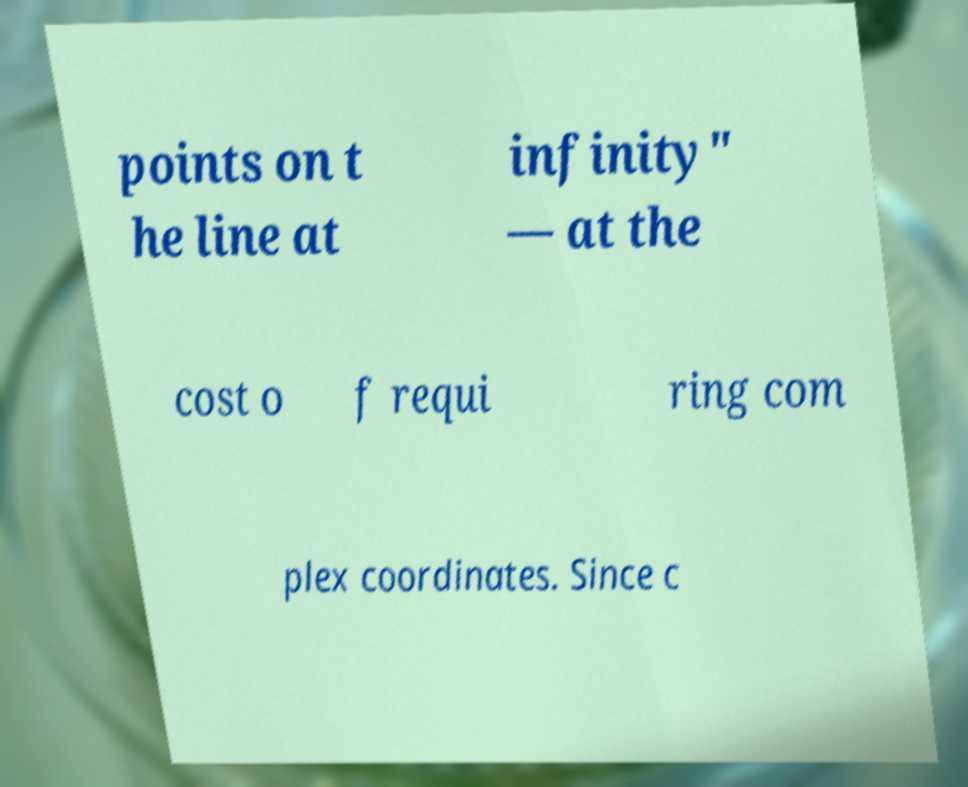There's text embedded in this image that I need extracted. Can you transcribe it verbatim? points on t he line at infinity" — at the cost o f requi ring com plex coordinates. Since c 